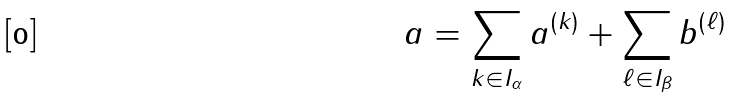<formula> <loc_0><loc_0><loc_500><loc_500>a = \sum _ { k \in I _ { \alpha } } a ^ { ( k ) } + \sum _ { \ell \in I _ { \beta } } b ^ { ( \ell ) }</formula> 